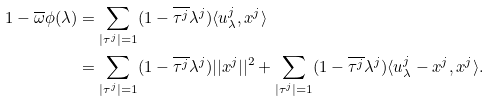<formula> <loc_0><loc_0><loc_500><loc_500>1 - \overline { \omega } \phi ( \lambda ) & = \sum _ { | \tau ^ { j } | = 1 } ( 1 - \overline { \tau ^ { j } } \lambda ^ { j } ) \langle u _ { \lambda } ^ { j } , x ^ { j } \rangle \\ & = \sum _ { | \tau ^ { j } | = 1 } ( 1 - \overline { \tau ^ { j } } \lambda ^ { j } ) | | x ^ { j } | | ^ { 2 } + \sum _ { | \tau ^ { j } | = 1 } ( 1 - \overline { \tau ^ { j } } \lambda ^ { j } ) \langle u _ { \lambda } ^ { j } - x ^ { j } , x ^ { j } \rangle .</formula> 